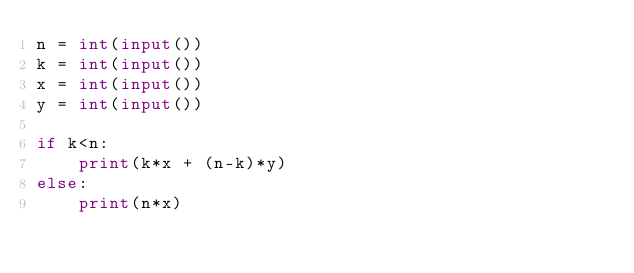Convert code to text. <code><loc_0><loc_0><loc_500><loc_500><_Python_>n = int(input())
k = int(input())
x = int(input())
y = int(input())

if k<n:
    print(k*x + (n-k)*y)
else:
    print(n*x)


</code> 